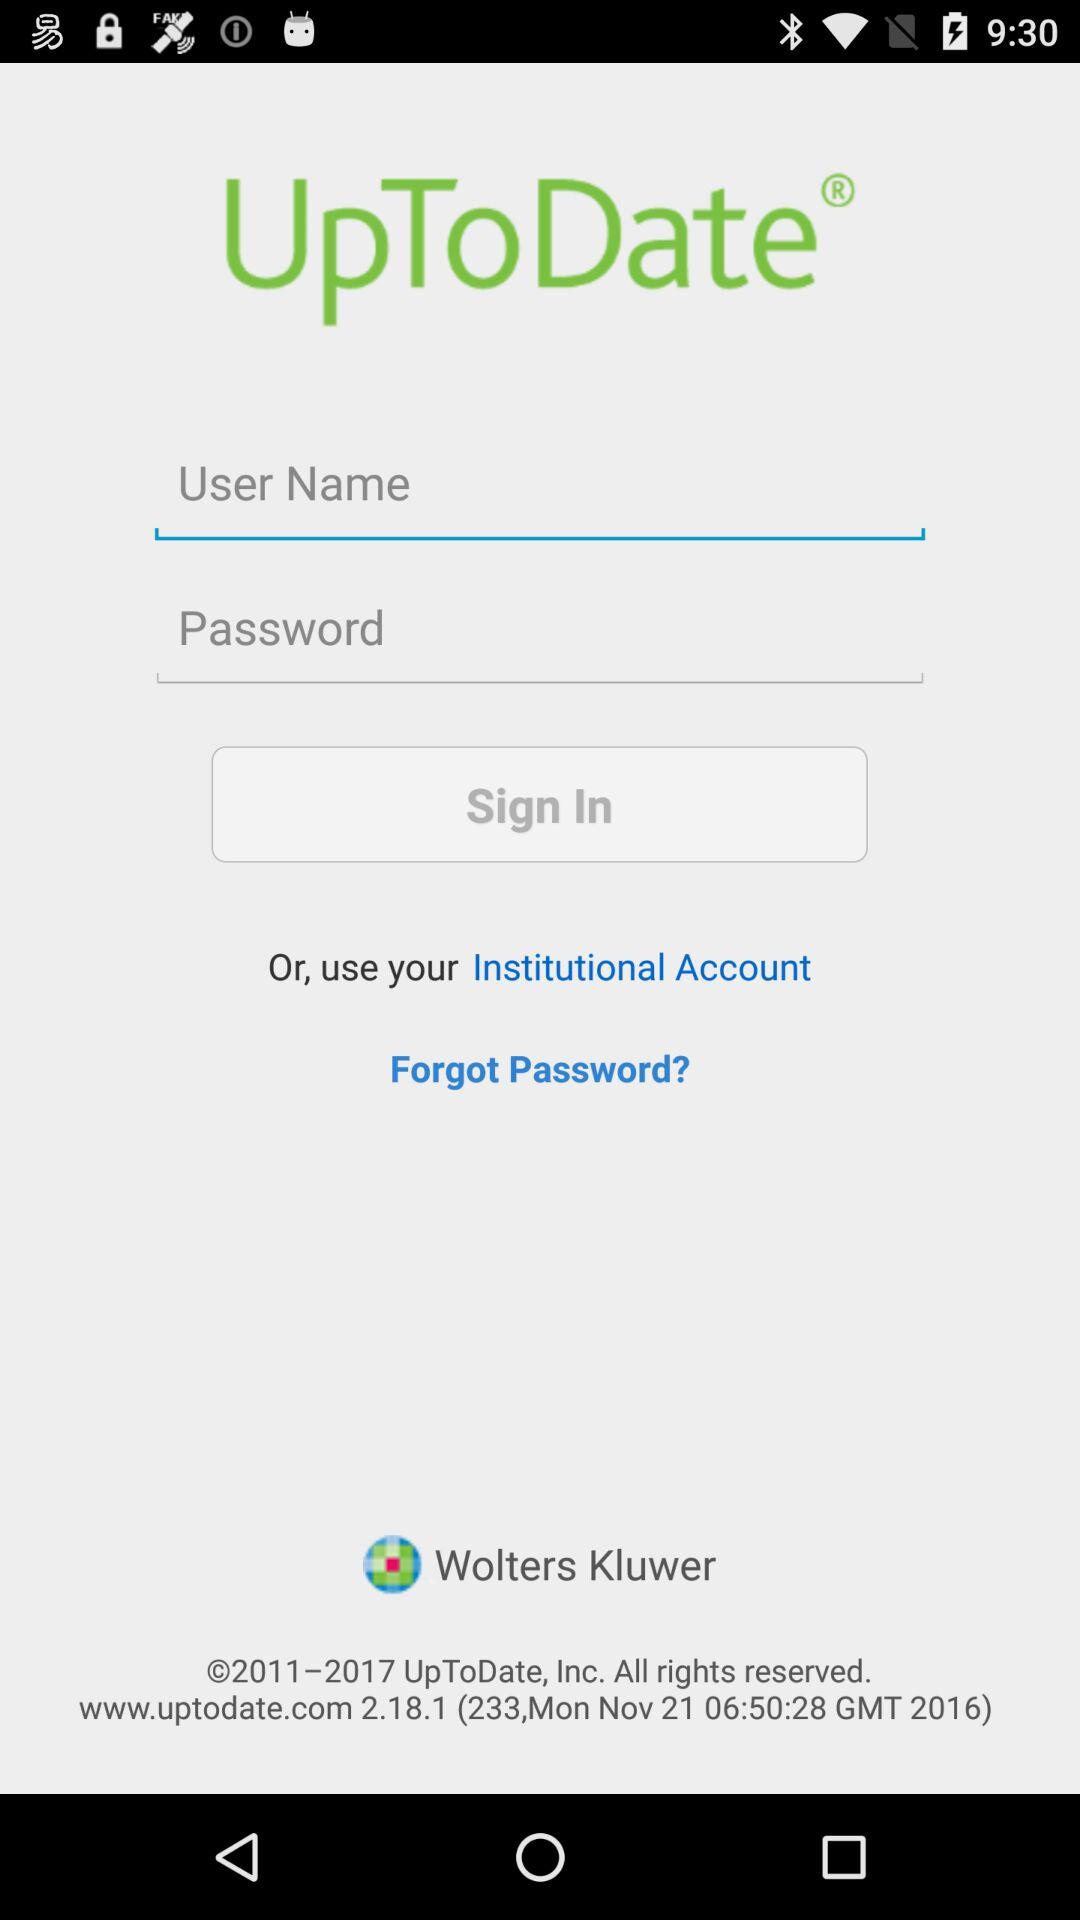What is the name of the application? The name of the application is "UpToDate". 